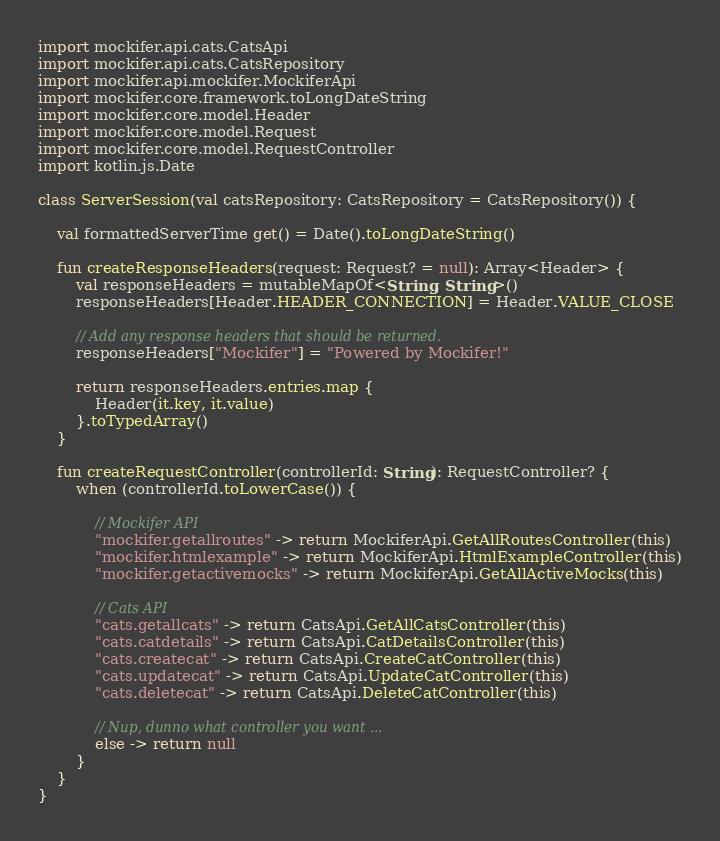Convert code to text. <code><loc_0><loc_0><loc_500><loc_500><_Kotlin_>import mockifer.api.cats.CatsApi
import mockifer.api.cats.CatsRepository
import mockifer.api.mockifer.MockiferApi
import mockifer.core.framework.toLongDateString
import mockifer.core.model.Header
import mockifer.core.model.Request
import mockifer.core.model.RequestController
import kotlin.js.Date

class ServerSession(val catsRepository: CatsRepository = CatsRepository()) {

    val formattedServerTime get() = Date().toLongDateString()

    fun createResponseHeaders(request: Request? = null): Array<Header> {
        val responseHeaders = mutableMapOf<String, String>()
        responseHeaders[Header.HEADER_CONNECTION] = Header.VALUE_CLOSE

        // Add any response headers that should be returned.
        responseHeaders["Mockifer"] = "Powered by Mockifer!"

        return responseHeaders.entries.map {
            Header(it.key, it.value)
        }.toTypedArray()
    }

    fun createRequestController(controllerId: String): RequestController? {
        when (controllerId.toLowerCase()) {

            // Mockifer API
            "mockifer.getallroutes" -> return MockiferApi.GetAllRoutesController(this)
            "mockifer.htmlexample" -> return MockiferApi.HtmlExampleController(this)
            "mockifer.getactivemocks" -> return MockiferApi.GetAllActiveMocks(this)

            // Cats API
            "cats.getallcats" -> return CatsApi.GetAllCatsController(this)
            "cats.catdetails" -> return CatsApi.CatDetailsController(this)
            "cats.createcat" -> return CatsApi.CreateCatController(this)
            "cats.updatecat" -> return CatsApi.UpdateCatController(this)
            "cats.deletecat" -> return CatsApi.DeleteCatController(this)

            // Nup, dunno what controller you want ...
            else -> return null
        }
    }
}
</code> 